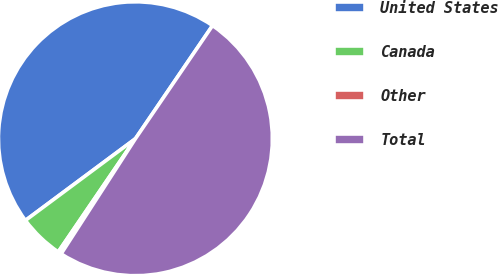<chart> <loc_0><loc_0><loc_500><loc_500><pie_chart><fcel>United States<fcel>Canada<fcel>Other<fcel>Total<nl><fcel>44.69%<fcel>5.31%<fcel>0.4%<fcel>49.6%<nl></chart> 